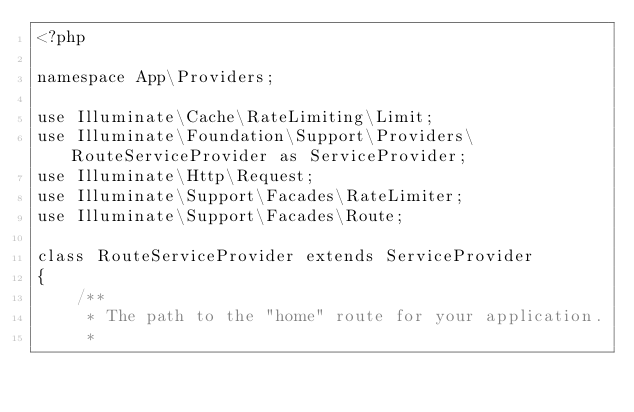<code> <loc_0><loc_0><loc_500><loc_500><_PHP_><?php

namespace App\Providers;

use Illuminate\Cache\RateLimiting\Limit;
use Illuminate\Foundation\Support\Providers\RouteServiceProvider as ServiceProvider;
use Illuminate\Http\Request;
use Illuminate\Support\Facades\RateLimiter;
use Illuminate\Support\Facades\Route;

class RouteServiceProvider extends ServiceProvider
{
    /**
     * The path to the "home" route for your application.
     *</code> 